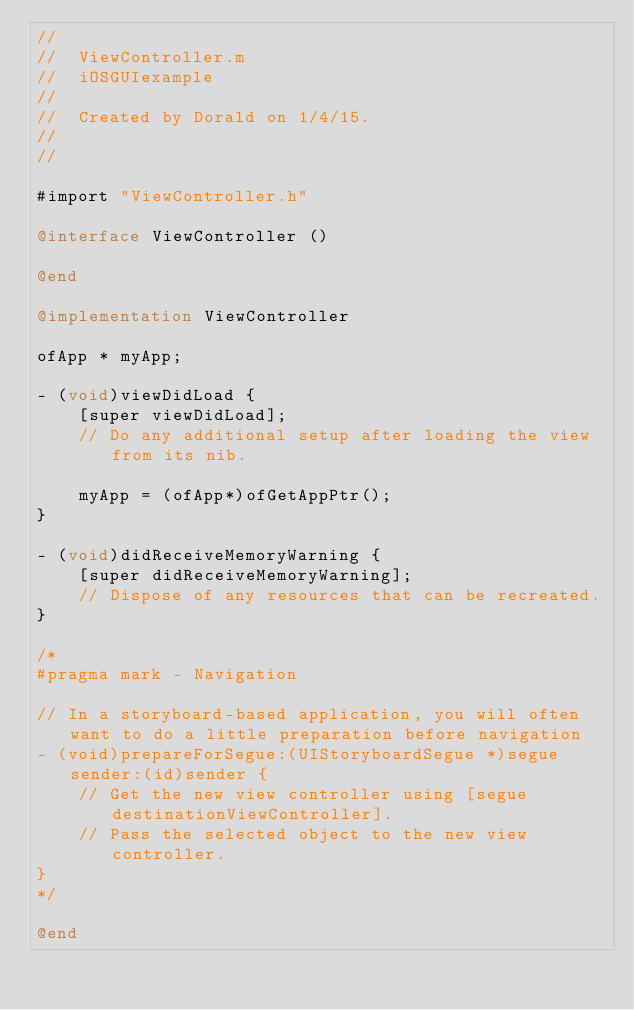<code> <loc_0><loc_0><loc_500><loc_500><_ObjectiveC_>//
//  ViewController.m
//  iOSGUIexample
//
//  Created by Dorald on 1/4/15.
//
//

#import "ViewController.h"

@interface ViewController ()

@end

@implementation ViewController

ofApp * myApp;

- (void)viewDidLoad {
    [super viewDidLoad];
    // Do any additional setup after loading the view from its nib.
    
    myApp = (ofApp*)ofGetAppPtr();
}

- (void)didReceiveMemoryWarning {
    [super didReceiveMemoryWarning];
    // Dispose of any resources that can be recreated.
}

/*
#pragma mark - Navigation

// In a storyboard-based application, you will often want to do a little preparation before navigation
- (void)prepareForSegue:(UIStoryboardSegue *)segue sender:(id)sender {
    // Get the new view controller using [segue destinationViewController].
    // Pass the selected object to the new view controller.
}
*/

@end
</code> 